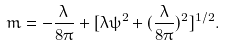<formula> <loc_0><loc_0><loc_500><loc_500>m = - \frac { \lambda } { 8 \pi } + [ \lambda \psi ^ { 2 } + ( \frac { \lambda } { 8 \pi } ) ^ { 2 } ] ^ { 1 / 2 } .</formula> 